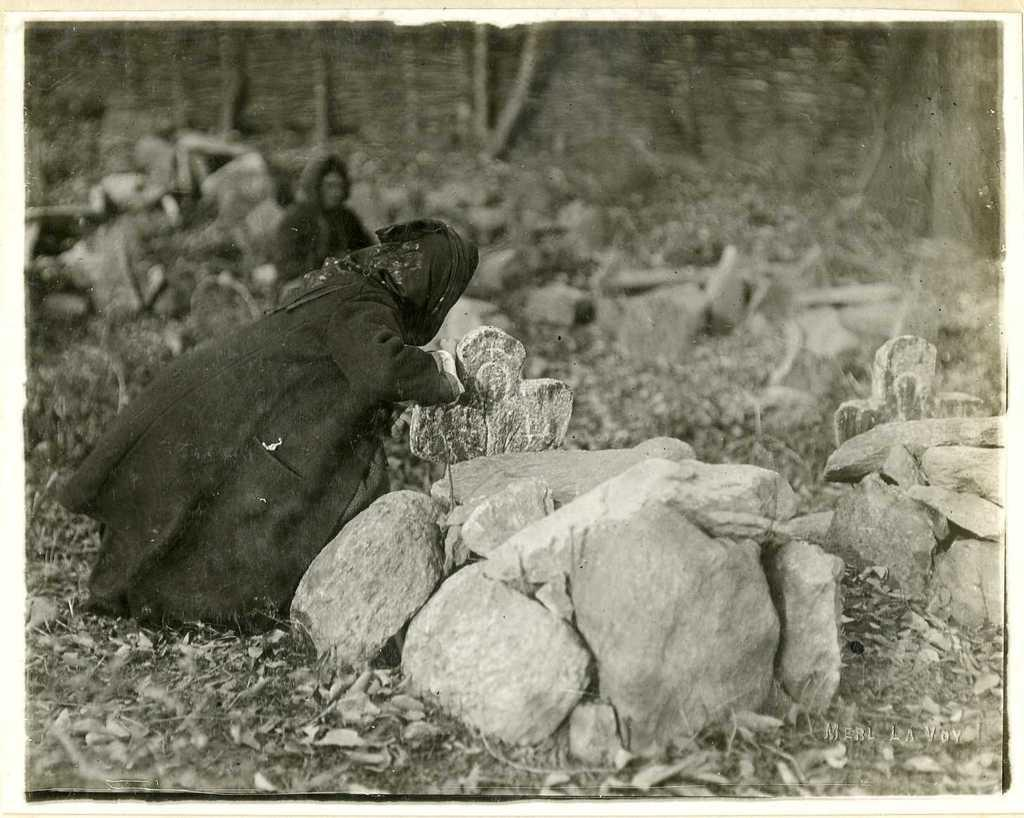What is the color scheme of the image? The image is black and white. How many people are in the image? There are two people in the image. Where are the people located in the image? The people are on the land. What can be found on the land in the image? There are cemeteries on the land, which have rocks and dried leaves. What type of vegetation is visible at the top of the image? There are trees at the top of the image. What type of crime is being committed in the image? There is no indication of any crime being committed in the image. Can you tell me how many chess pieces are on the land in the image? There are no chess pieces visible in the image. 